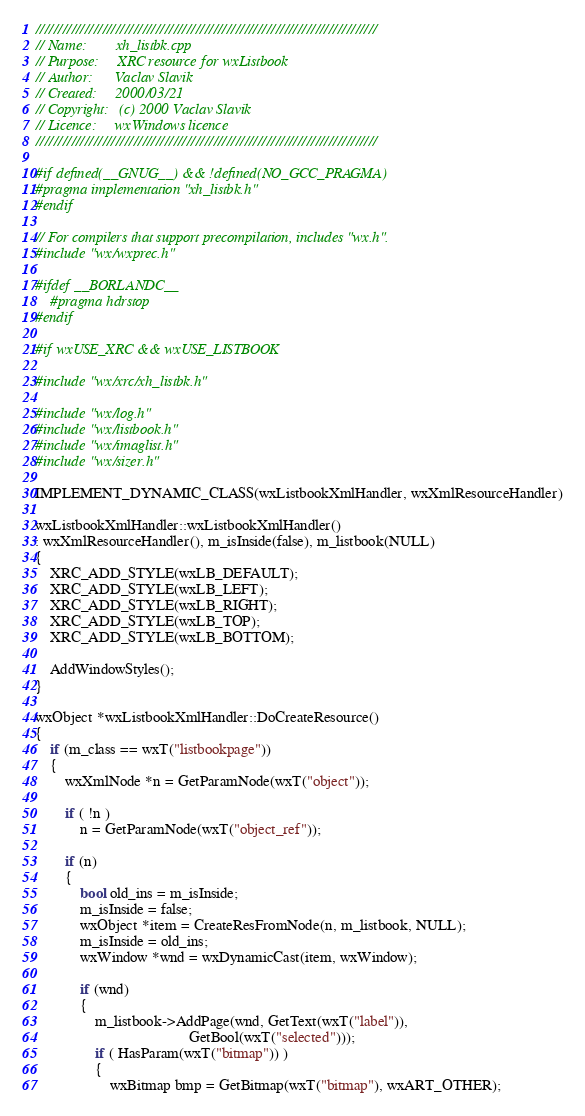Convert code to text. <code><loc_0><loc_0><loc_500><loc_500><_C++_>/////////////////////////////////////////////////////////////////////////////
// Name:        xh_listbk.cpp
// Purpose:     XRC resource for wxListbook
// Author:      Vaclav Slavik
// Created:     2000/03/21
// Copyright:   (c) 2000 Vaclav Slavik
// Licence:     wxWindows licence
/////////////////////////////////////////////////////////////////////////////

#if defined(__GNUG__) && !defined(NO_GCC_PRAGMA)
#pragma implementation "xh_listbk.h"
#endif

// For compilers that support precompilation, includes "wx.h".
#include "wx/wxprec.h"

#ifdef __BORLANDC__
    #pragma hdrstop
#endif

#if wxUSE_XRC && wxUSE_LISTBOOK

#include "wx/xrc/xh_listbk.h"

#include "wx/log.h"
#include "wx/listbook.h"
#include "wx/imaglist.h"
#include "wx/sizer.h"

IMPLEMENT_DYNAMIC_CLASS(wxListbookXmlHandler, wxXmlResourceHandler)

wxListbookXmlHandler::wxListbookXmlHandler()
: wxXmlResourceHandler(), m_isInside(false), m_listbook(NULL)
{
    XRC_ADD_STYLE(wxLB_DEFAULT);
    XRC_ADD_STYLE(wxLB_LEFT);
    XRC_ADD_STYLE(wxLB_RIGHT);
    XRC_ADD_STYLE(wxLB_TOP);
    XRC_ADD_STYLE(wxLB_BOTTOM);

    AddWindowStyles();
}

wxObject *wxListbookXmlHandler::DoCreateResource()
{
    if (m_class == wxT("listbookpage"))
    {
        wxXmlNode *n = GetParamNode(wxT("object"));

        if ( !n )
            n = GetParamNode(wxT("object_ref"));

        if (n)
        {
            bool old_ins = m_isInside;
            m_isInside = false;
            wxObject *item = CreateResFromNode(n, m_listbook, NULL);
            m_isInside = old_ins;
            wxWindow *wnd = wxDynamicCast(item, wxWindow);

            if (wnd)
            {
                m_listbook->AddPage(wnd, GetText(wxT("label")),
                                         GetBool(wxT("selected")));
                if ( HasParam(wxT("bitmap")) )
                {
                    wxBitmap bmp = GetBitmap(wxT("bitmap"), wxART_OTHER);</code> 